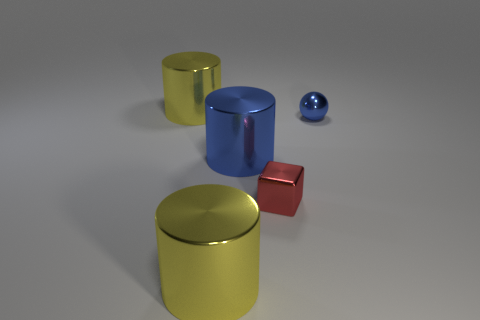The small thing that is made of the same material as the small red block is what color?
Provide a short and direct response. Blue. Is there anything else that has the same size as the red cube?
Your response must be concise. Yes. How many blue metallic spheres are right of the small metal sphere?
Your answer should be very brief. 0. Is the color of the cylinder in front of the tiny red thing the same as the shiny object that is right of the tiny red block?
Ensure brevity in your answer.  No. Is there any other thing that has the same shape as the small red metallic thing?
Your answer should be compact. No. There is a thing in front of the tiny shiny block; is its shape the same as the blue shiny thing that is in front of the small blue shiny sphere?
Provide a short and direct response. Yes. There is a shiny block; is it the same size as the yellow thing that is behind the small red thing?
Your answer should be very brief. No. Is the number of blocks greater than the number of large objects?
Give a very brief answer. No. Are the big yellow object in front of the blue sphere and the small object that is behind the red block made of the same material?
Offer a terse response. Yes. What is the block made of?
Make the answer very short. Metal. 